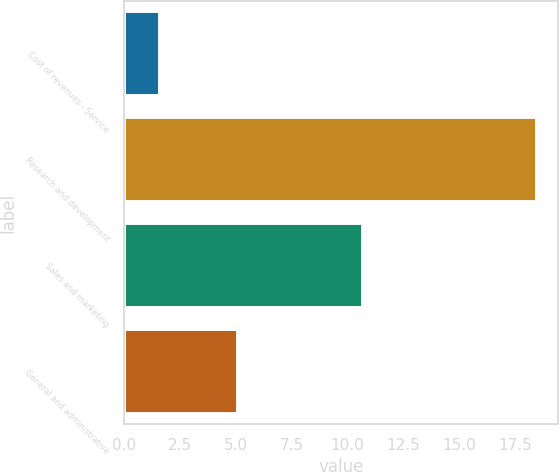<chart> <loc_0><loc_0><loc_500><loc_500><bar_chart><fcel>Cost of revenues - Service<fcel>Research and development<fcel>Sales and marketing<fcel>General and administrative<nl><fcel>1.6<fcel>18.5<fcel>10.7<fcel>5.1<nl></chart> 